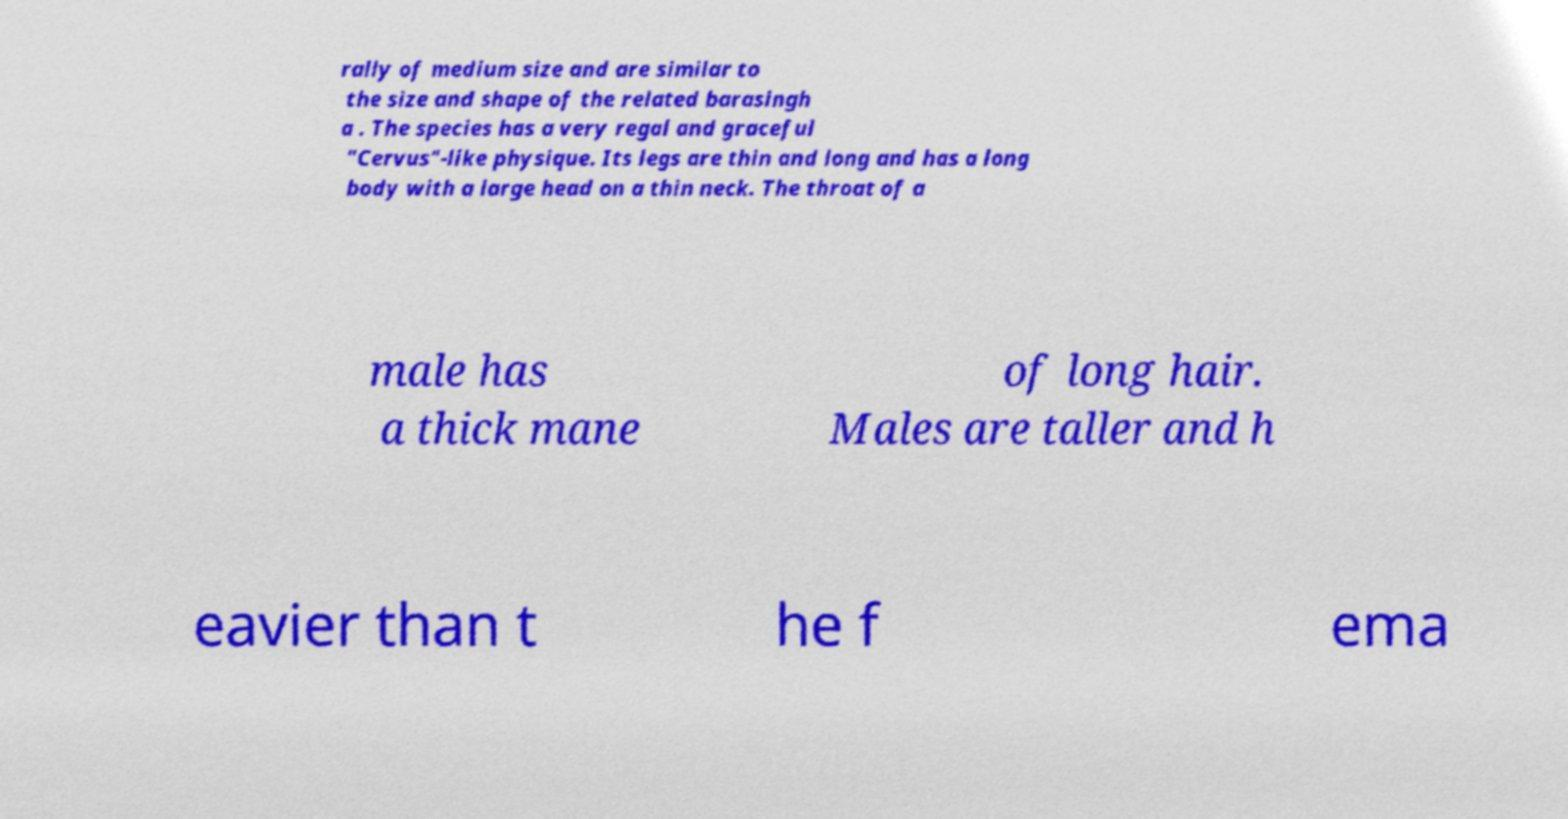What messages or text are displayed in this image? I need them in a readable, typed format. rally of medium size and are similar to the size and shape of the related barasingh a . The species has a very regal and graceful "Cervus"-like physique. Its legs are thin and long and has a long body with a large head on a thin neck. The throat of a male has a thick mane of long hair. Males are taller and h eavier than t he f ema 